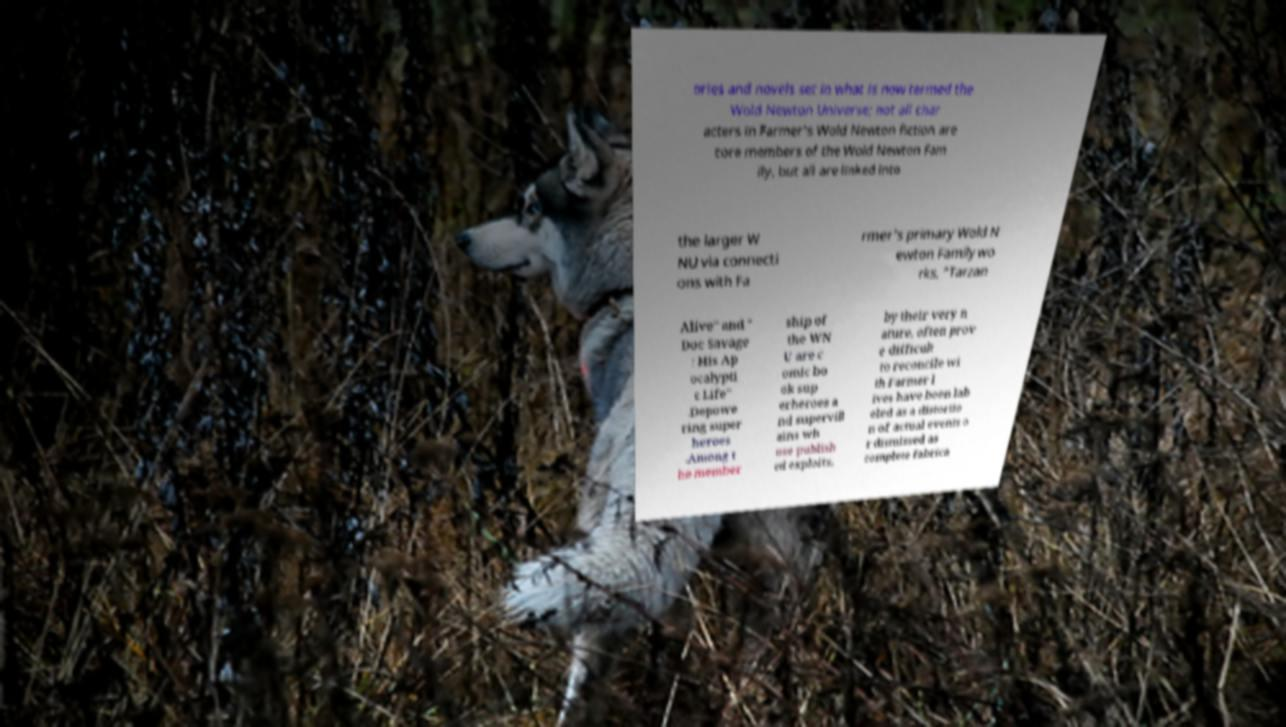Could you extract and type out the text from this image? ories and novels set in what is now termed the Wold Newton Universe; not all char acters in Farmer's Wold Newton fiction are core members of the Wold Newton Fam ily, but all are linked into the larger W NU via connecti ons with Fa rmer's primary Wold N ewton Family wo rks, "Tarzan Alive" and " Doc Savage : His Ap ocalypti c Life" .Depowe ring super heroes .Among t he member ship of the WN U are c omic bo ok sup erheroes a nd supervill ains wh ose publish ed exploits, by their very n ature, often prov e difficult to reconcile wi th Farmer l ives have been lab eled as a distortio n of actual events o r dismissed as complete fabrica 